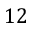Convert formula to latex. <formula><loc_0><loc_0><loc_500><loc_500>1 2</formula> 